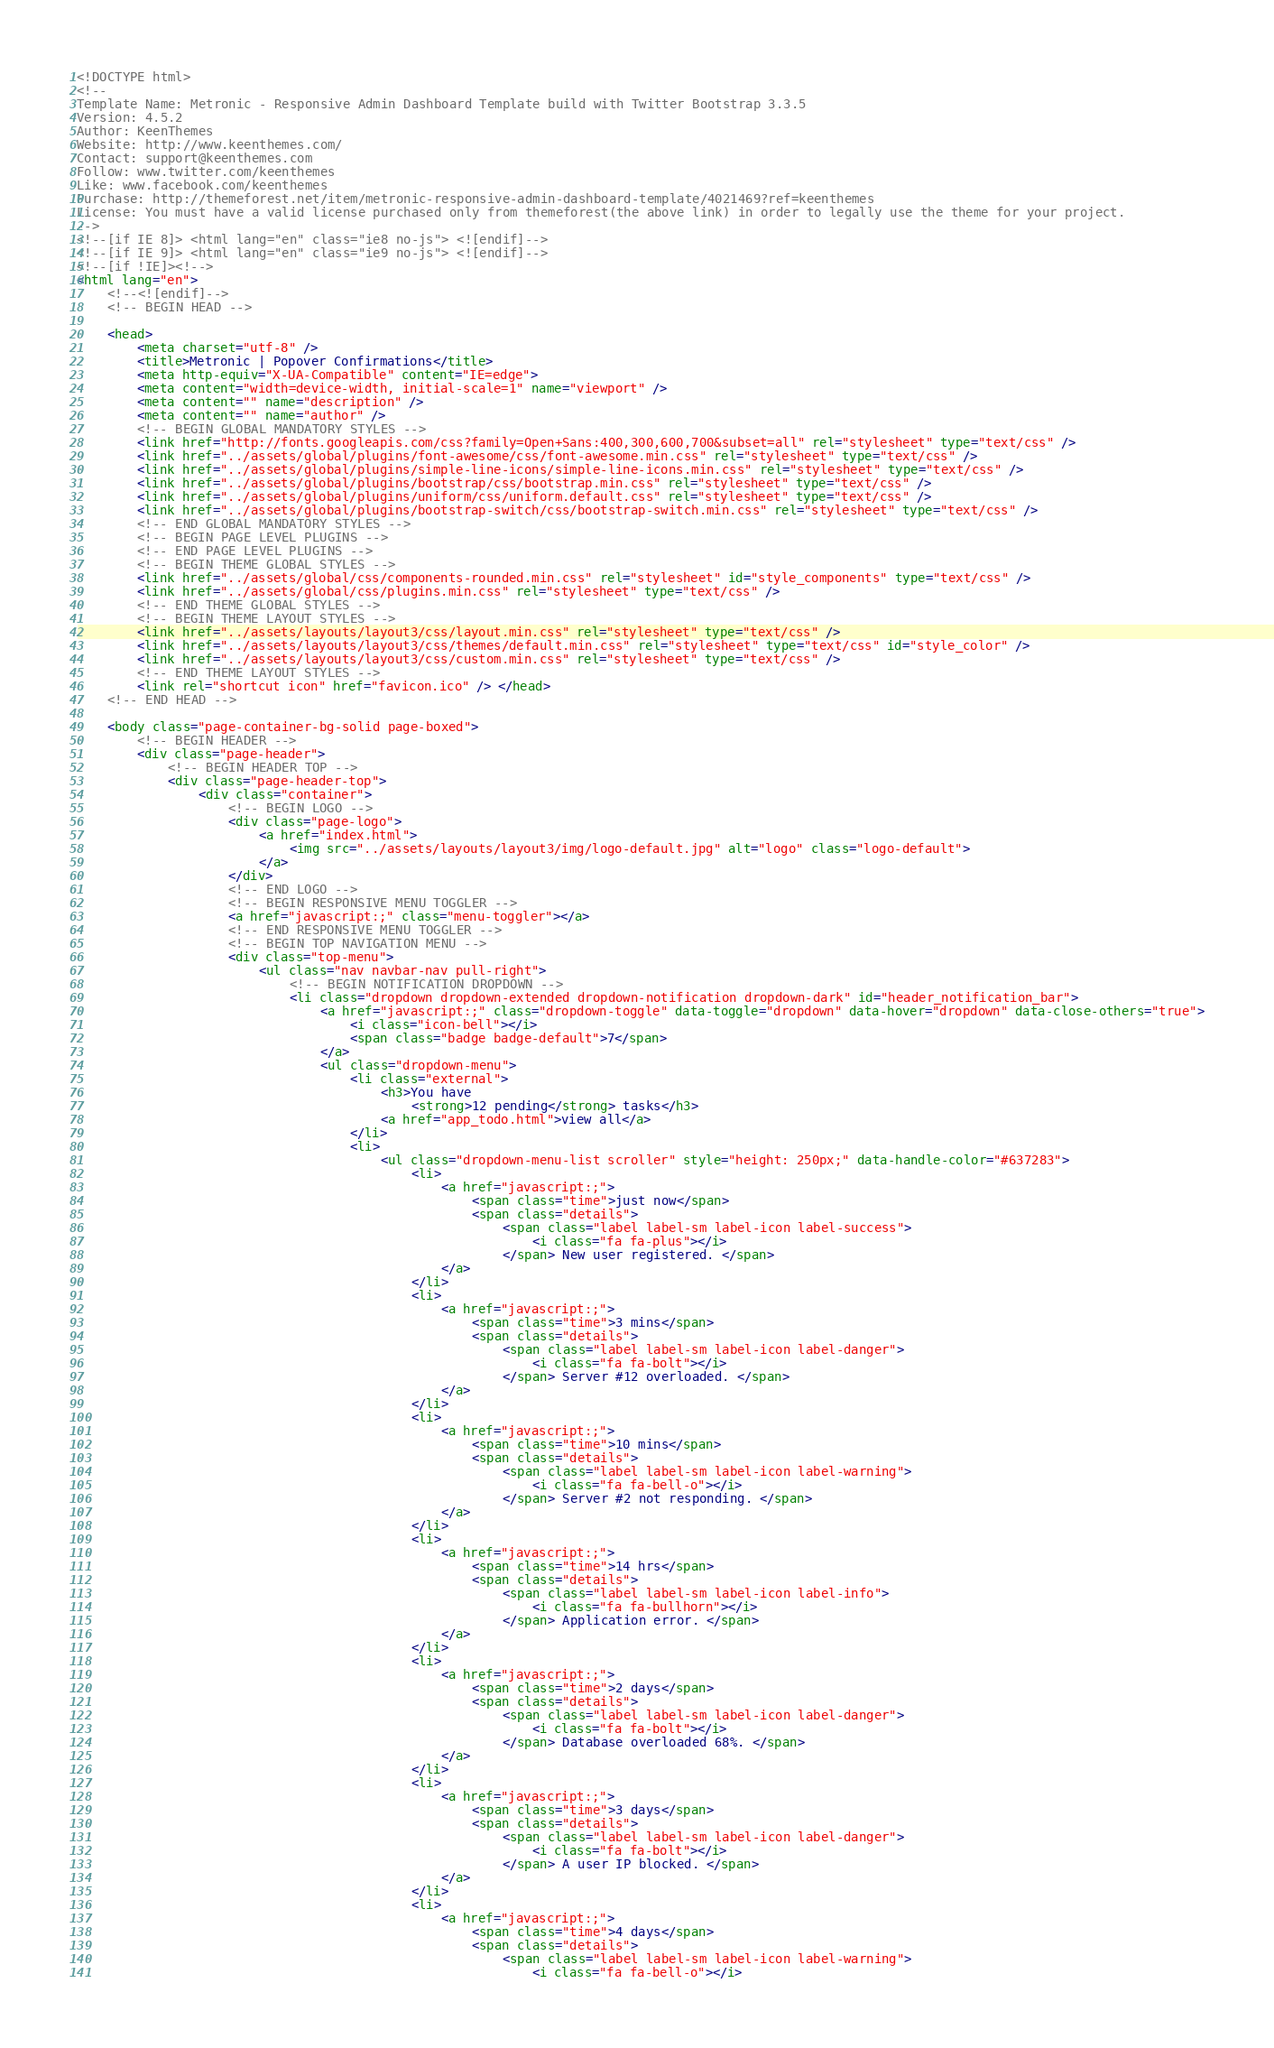<code> <loc_0><loc_0><loc_500><loc_500><_HTML_><!DOCTYPE html>
<!-- 
Template Name: Metronic - Responsive Admin Dashboard Template build with Twitter Bootstrap 3.3.5
Version: 4.5.2
Author: KeenThemes
Website: http://www.keenthemes.com/
Contact: support@keenthemes.com
Follow: www.twitter.com/keenthemes
Like: www.facebook.com/keenthemes
Purchase: http://themeforest.net/item/metronic-responsive-admin-dashboard-template/4021469?ref=keenthemes
License: You must have a valid license purchased only from themeforest(the above link) in order to legally use the theme for your project.
-->
<!--[if IE 8]> <html lang="en" class="ie8 no-js"> <![endif]-->
<!--[if IE 9]> <html lang="en" class="ie9 no-js"> <![endif]-->
<!--[if !IE]><!-->
<html lang="en">
    <!--<![endif]-->
    <!-- BEGIN HEAD -->

    <head>
        <meta charset="utf-8" />
        <title>Metronic | Popover Confirmations</title>
        <meta http-equiv="X-UA-Compatible" content="IE=edge">
        <meta content="width=device-width, initial-scale=1" name="viewport" />
        <meta content="" name="description" />
        <meta content="" name="author" />
        <!-- BEGIN GLOBAL MANDATORY STYLES -->
        <link href="http://fonts.googleapis.com/css?family=Open+Sans:400,300,600,700&subset=all" rel="stylesheet" type="text/css" />
        <link href="../assets/global/plugins/font-awesome/css/font-awesome.min.css" rel="stylesheet" type="text/css" />
        <link href="../assets/global/plugins/simple-line-icons/simple-line-icons.min.css" rel="stylesheet" type="text/css" />
        <link href="../assets/global/plugins/bootstrap/css/bootstrap.min.css" rel="stylesheet" type="text/css" />
        <link href="../assets/global/plugins/uniform/css/uniform.default.css" rel="stylesheet" type="text/css" />
        <link href="../assets/global/plugins/bootstrap-switch/css/bootstrap-switch.min.css" rel="stylesheet" type="text/css" />
        <!-- END GLOBAL MANDATORY STYLES -->
        <!-- BEGIN PAGE LEVEL PLUGINS -->
        <!-- END PAGE LEVEL PLUGINS -->
        <!-- BEGIN THEME GLOBAL STYLES -->
        <link href="../assets/global/css/components-rounded.min.css" rel="stylesheet" id="style_components" type="text/css" />
        <link href="../assets/global/css/plugins.min.css" rel="stylesheet" type="text/css" />
        <!-- END THEME GLOBAL STYLES -->
        <!-- BEGIN THEME LAYOUT STYLES -->
        <link href="../assets/layouts/layout3/css/layout.min.css" rel="stylesheet" type="text/css" />
        <link href="../assets/layouts/layout3/css/themes/default.min.css" rel="stylesheet" type="text/css" id="style_color" />
        <link href="../assets/layouts/layout3/css/custom.min.css" rel="stylesheet" type="text/css" />
        <!-- END THEME LAYOUT STYLES -->
        <link rel="shortcut icon" href="favicon.ico" /> </head>
    <!-- END HEAD -->

    <body class="page-container-bg-solid page-boxed">
        <!-- BEGIN HEADER -->
        <div class="page-header">
            <!-- BEGIN HEADER TOP -->
            <div class="page-header-top">
                <div class="container">
                    <!-- BEGIN LOGO -->
                    <div class="page-logo">
                        <a href="index.html">
                            <img src="../assets/layouts/layout3/img/logo-default.jpg" alt="logo" class="logo-default">
                        </a>
                    </div>
                    <!-- END LOGO -->
                    <!-- BEGIN RESPONSIVE MENU TOGGLER -->
                    <a href="javascript:;" class="menu-toggler"></a>
                    <!-- END RESPONSIVE MENU TOGGLER -->
                    <!-- BEGIN TOP NAVIGATION MENU -->
                    <div class="top-menu">
                        <ul class="nav navbar-nav pull-right">
                            <!-- BEGIN NOTIFICATION DROPDOWN -->
                            <li class="dropdown dropdown-extended dropdown-notification dropdown-dark" id="header_notification_bar">
                                <a href="javascript:;" class="dropdown-toggle" data-toggle="dropdown" data-hover="dropdown" data-close-others="true">
                                    <i class="icon-bell"></i>
                                    <span class="badge badge-default">7</span>
                                </a>
                                <ul class="dropdown-menu">
                                    <li class="external">
                                        <h3>You have
                                            <strong>12 pending</strong> tasks</h3>
                                        <a href="app_todo.html">view all</a>
                                    </li>
                                    <li>
                                        <ul class="dropdown-menu-list scroller" style="height: 250px;" data-handle-color="#637283">
                                            <li>
                                                <a href="javascript:;">
                                                    <span class="time">just now</span>
                                                    <span class="details">
                                                        <span class="label label-sm label-icon label-success">
                                                            <i class="fa fa-plus"></i>
                                                        </span> New user registered. </span>
                                                </a>
                                            </li>
                                            <li>
                                                <a href="javascript:;">
                                                    <span class="time">3 mins</span>
                                                    <span class="details">
                                                        <span class="label label-sm label-icon label-danger">
                                                            <i class="fa fa-bolt"></i>
                                                        </span> Server #12 overloaded. </span>
                                                </a>
                                            </li>
                                            <li>
                                                <a href="javascript:;">
                                                    <span class="time">10 mins</span>
                                                    <span class="details">
                                                        <span class="label label-sm label-icon label-warning">
                                                            <i class="fa fa-bell-o"></i>
                                                        </span> Server #2 not responding. </span>
                                                </a>
                                            </li>
                                            <li>
                                                <a href="javascript:;">
                                                    <span class="time">14 hrs</span>
                                                    <span class="details">
                                                        <span class="label label-sm label-icon label-info">
                                                            <i class="fa fa-bullhorn"></i>
                                                        </span> Application error. </span>
                                                </a>
                                            </li>
                                            <li>
                                                <a href="javascript:;">
                                                    <span class="time">2 days</span>
                                                    <span class="details">
                                                        <span class="label label-sm label-icon label-danger">
                                                            <i class="fa fa-bolt"></i>
                                                        </span> Database overloaded 68%. </span>
                                                </a>
                                            </li>
                                            <li>
                                                <a href="javascript:;">
                                                    <span class="time">3 days</span>
                                                    <span class="details">
                                                        <span class="label label-sm label-icon label-danger">
                                                            <i class="fa fa-bolt"></i>
                                                        </span> A user IP blocked. </span>
                                                </a>
                                            </li>
                                            <li>
                                                <a href="javascript:;">
                                                    <span class="time">4 days</span>
                                                    <span class="details">
                                                        <span class="label label-sm label-icon label-warning">
                                                            <i class="fa fa-bell-o"></i></code> 